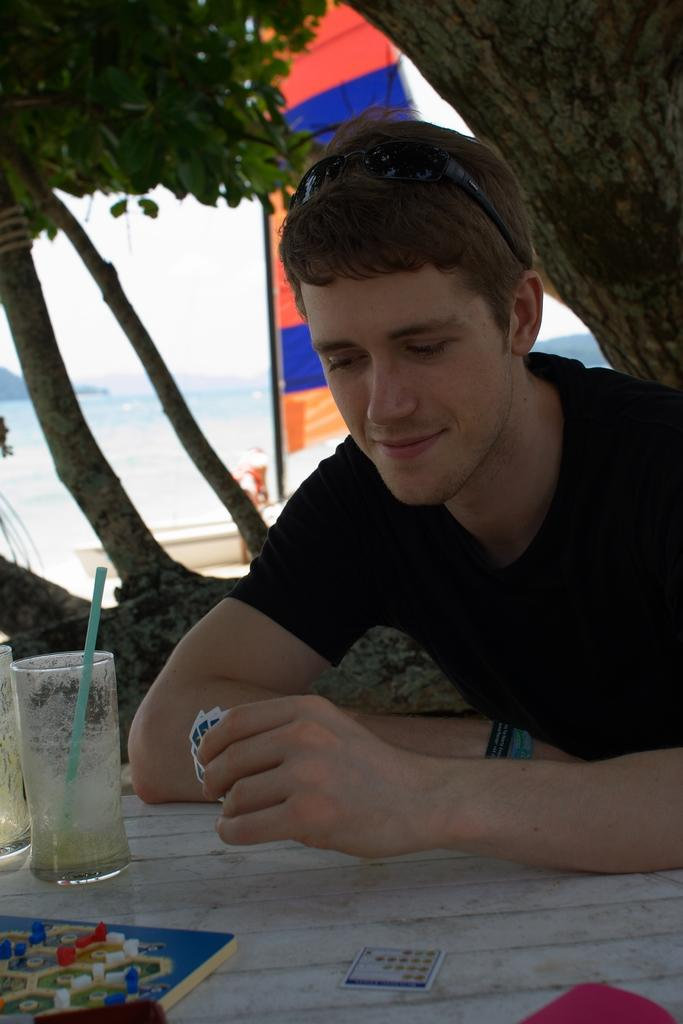Who is present in the image? There is a man in the image. What is in front of the man? There is a table in front of the man. What can be seen on the left side of the table? There are glasses on the left side of the table. What is visible at the top of the image? There is a tree visible at the top of the image. What is the nature of the water in the image? There is water present in the image. What type of education does the man have, as seen in the image? There is no information about the man's education in the image. 